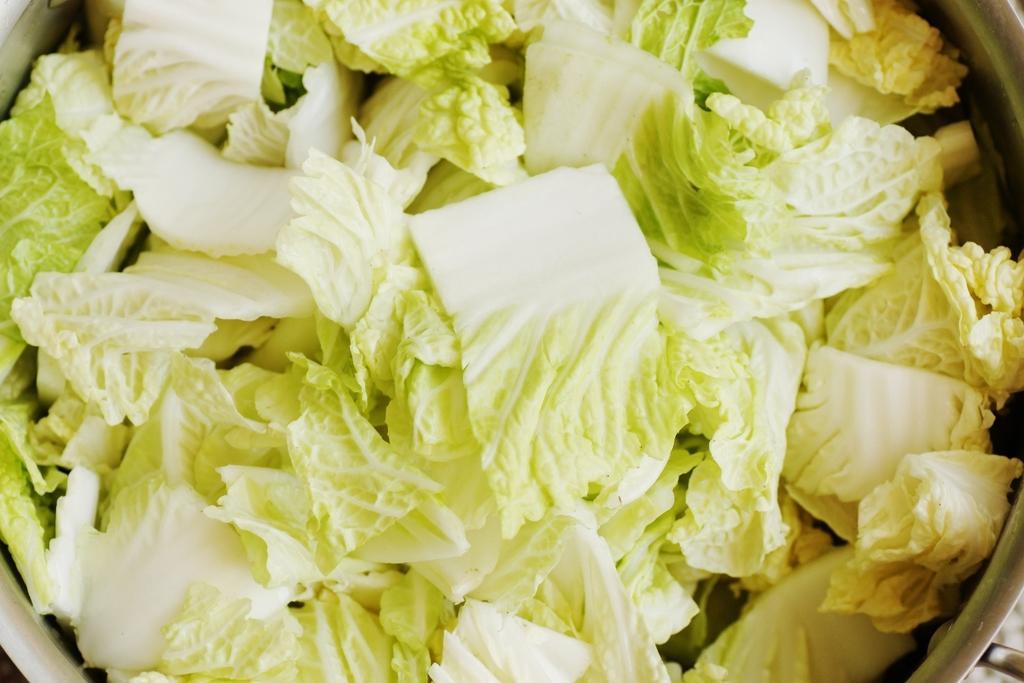Please provide a concise description of this image. In the picture we can see a bowl with cauliflower pieces in it. 